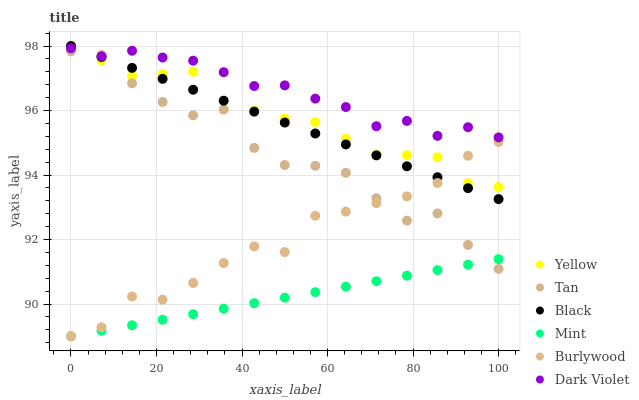Does Mint have the minimum area under the curve?
Answer yes or no. Yes. Does Dark Violet have the maximum area under the curve?
Answer yes or no. Yes. Does Black have the minimum area under the curve?
Answer yes or no. No. Does Black have the maximum area under the curve?
Answer yes or no. No. Is Mint the smoothest?
Answer yes or no. Yes. Is Tan the roughest?
Answer yes or no. Yes. Is Dark Violet the smoothest?
Answer yes or no. No. Is Dark Violet the roughest?
Answer yes or no. No. Does Burlywood have the lowest value?
Answer yes or no. Yes. Does Black have the lowest value?
Answer yes or no. No. Does Yellow have the highest value?
Answer yes or no. Yes. Does Dark Violet have the highest value?
Answer yes or no. No. Is Mint less than Yellow?
Answer yes or no. Yes. Is Yellow greater than Mint?
Answer yes or no. Yes. Does Mint intersect Tan?
Answer yes or no. Yes. Is Mint less than Tan?
Answer yes or no. No. Is Mint greater than Tan?
Answer yes or no. No. Does Mint intersect Yellow?
Answer yes or no. No. 